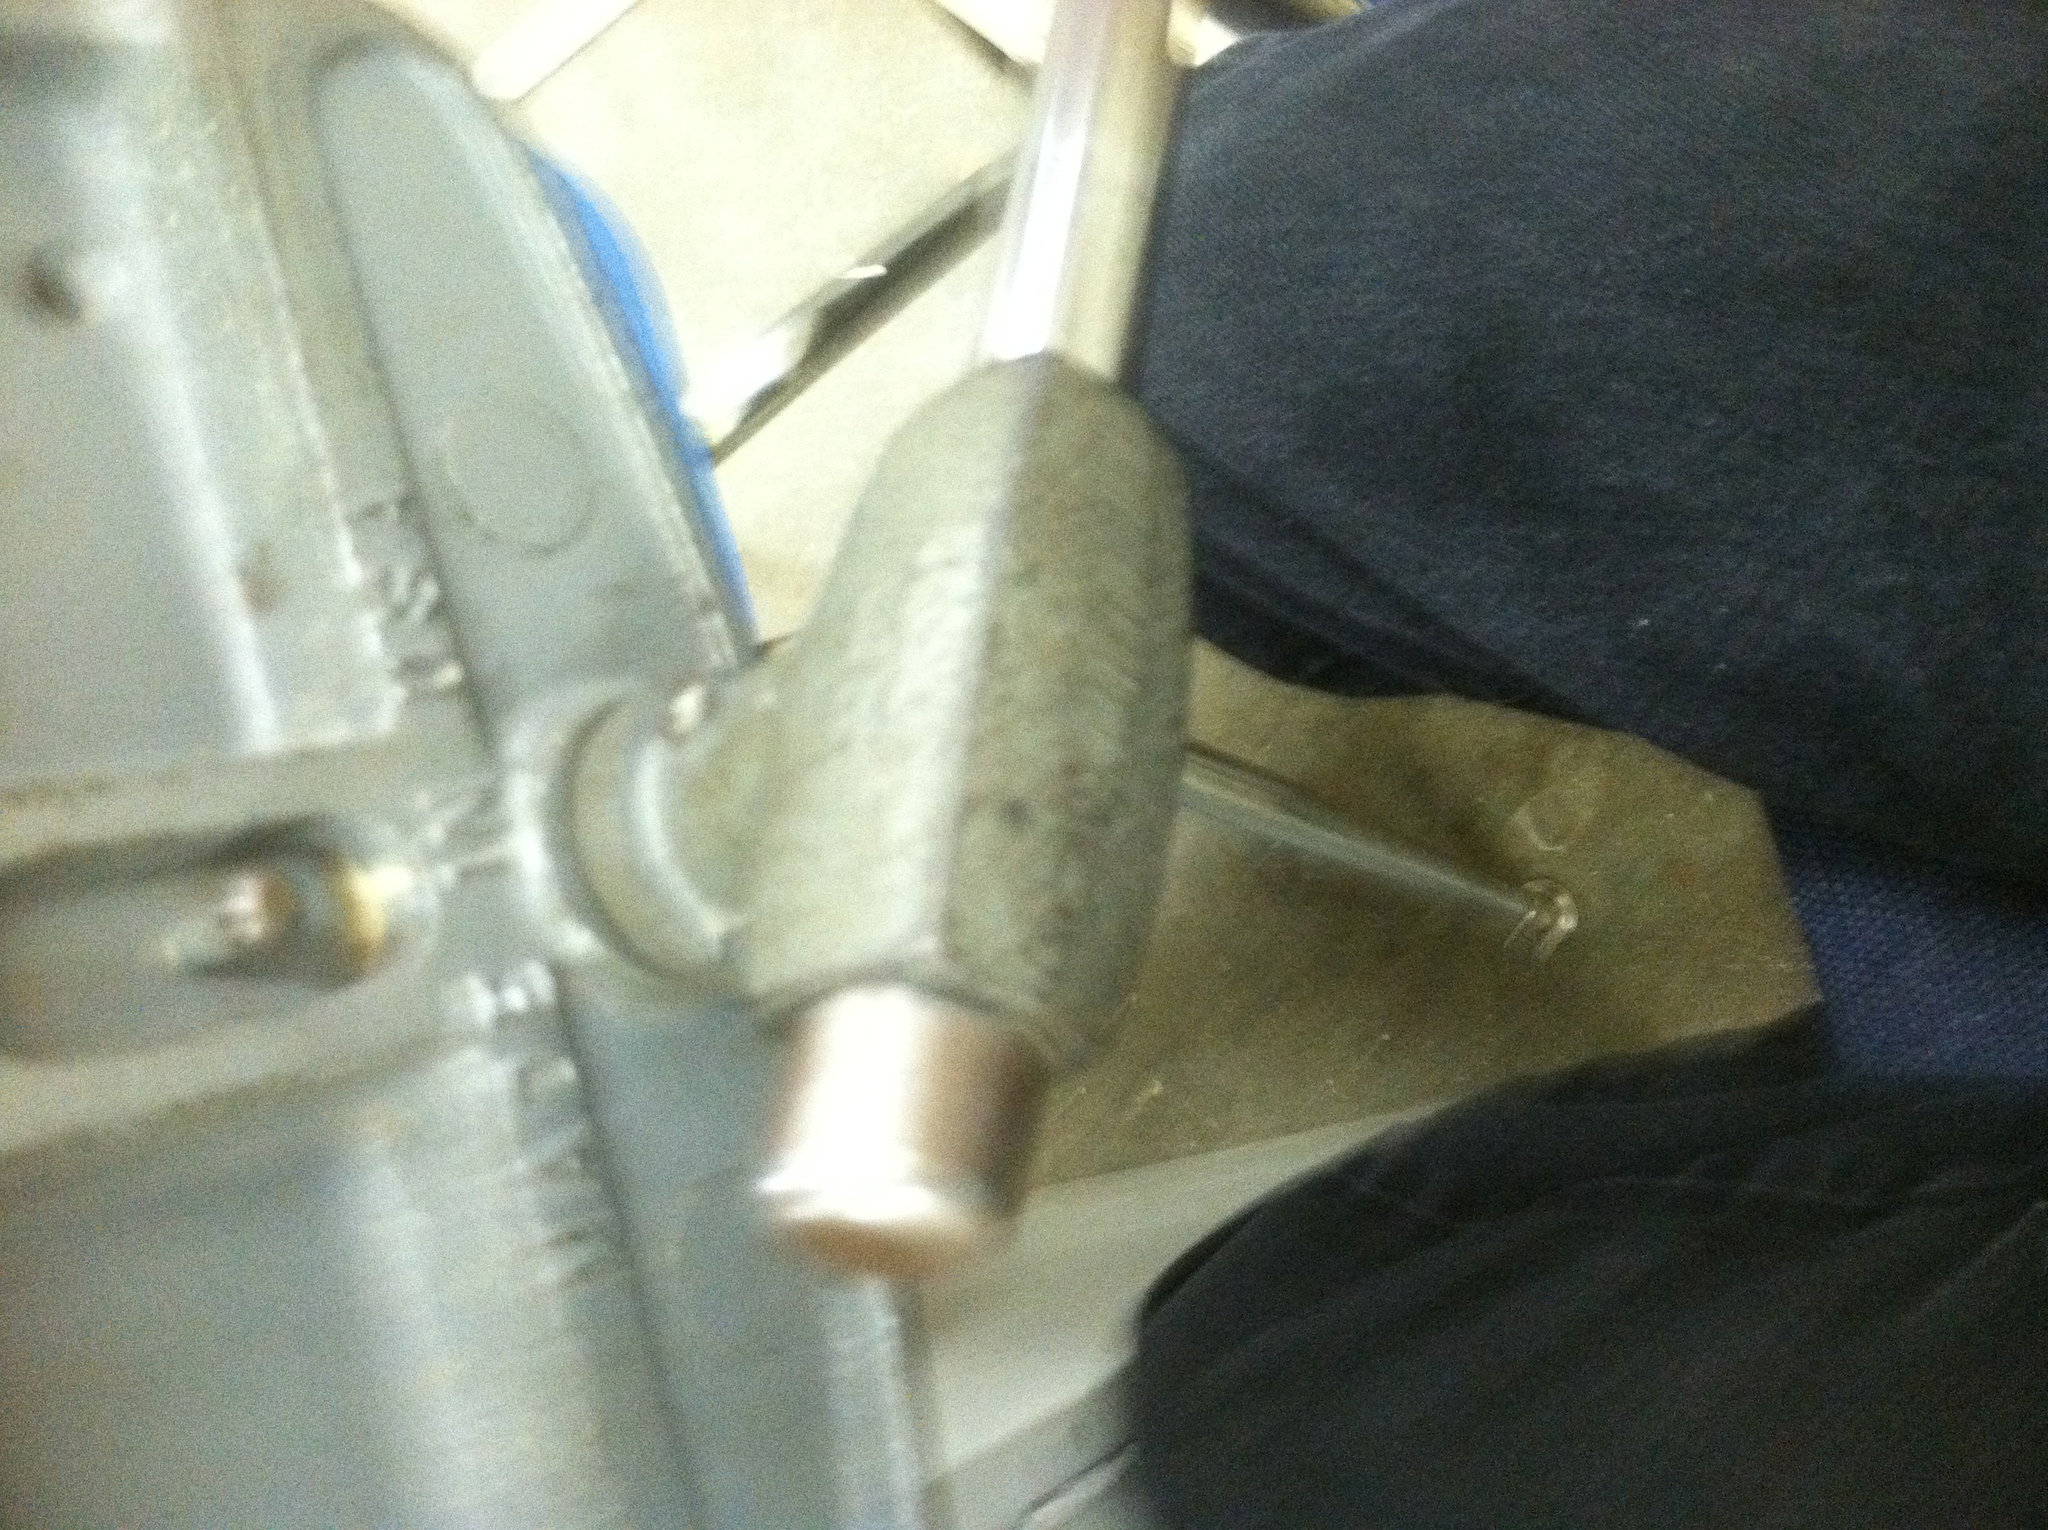Tell a story involving this vise in a hobbyist's garage. In a cozy garage-turned-workshop, an avid hobbyist named Alex spends their weekends working on intricate woodworking projects. One spring afternoon, Alex decided to craft a beautiful wooden jewelry box for their partner's birthday. The vise, a trusty and well-worn tool in their workshop, played a crucial role in this undertaking. As Alex meticulously cut and shaped each piece of wood, the vise held the components steady, ensuring every cut was precise and the joints perfectly formed. The smell of sawdust filled the air as the box slowly took shape. After hours of dedicated work, the final product was a stunning jewelry box, with delicate carvings and intricate joinery, all made possible by the reliable hold of the vise. When Alex presented the box to their partner, the look of joy and surprise was worth every moment spent in the garage, making the vise not just a tool, but a part of their shared memories. 